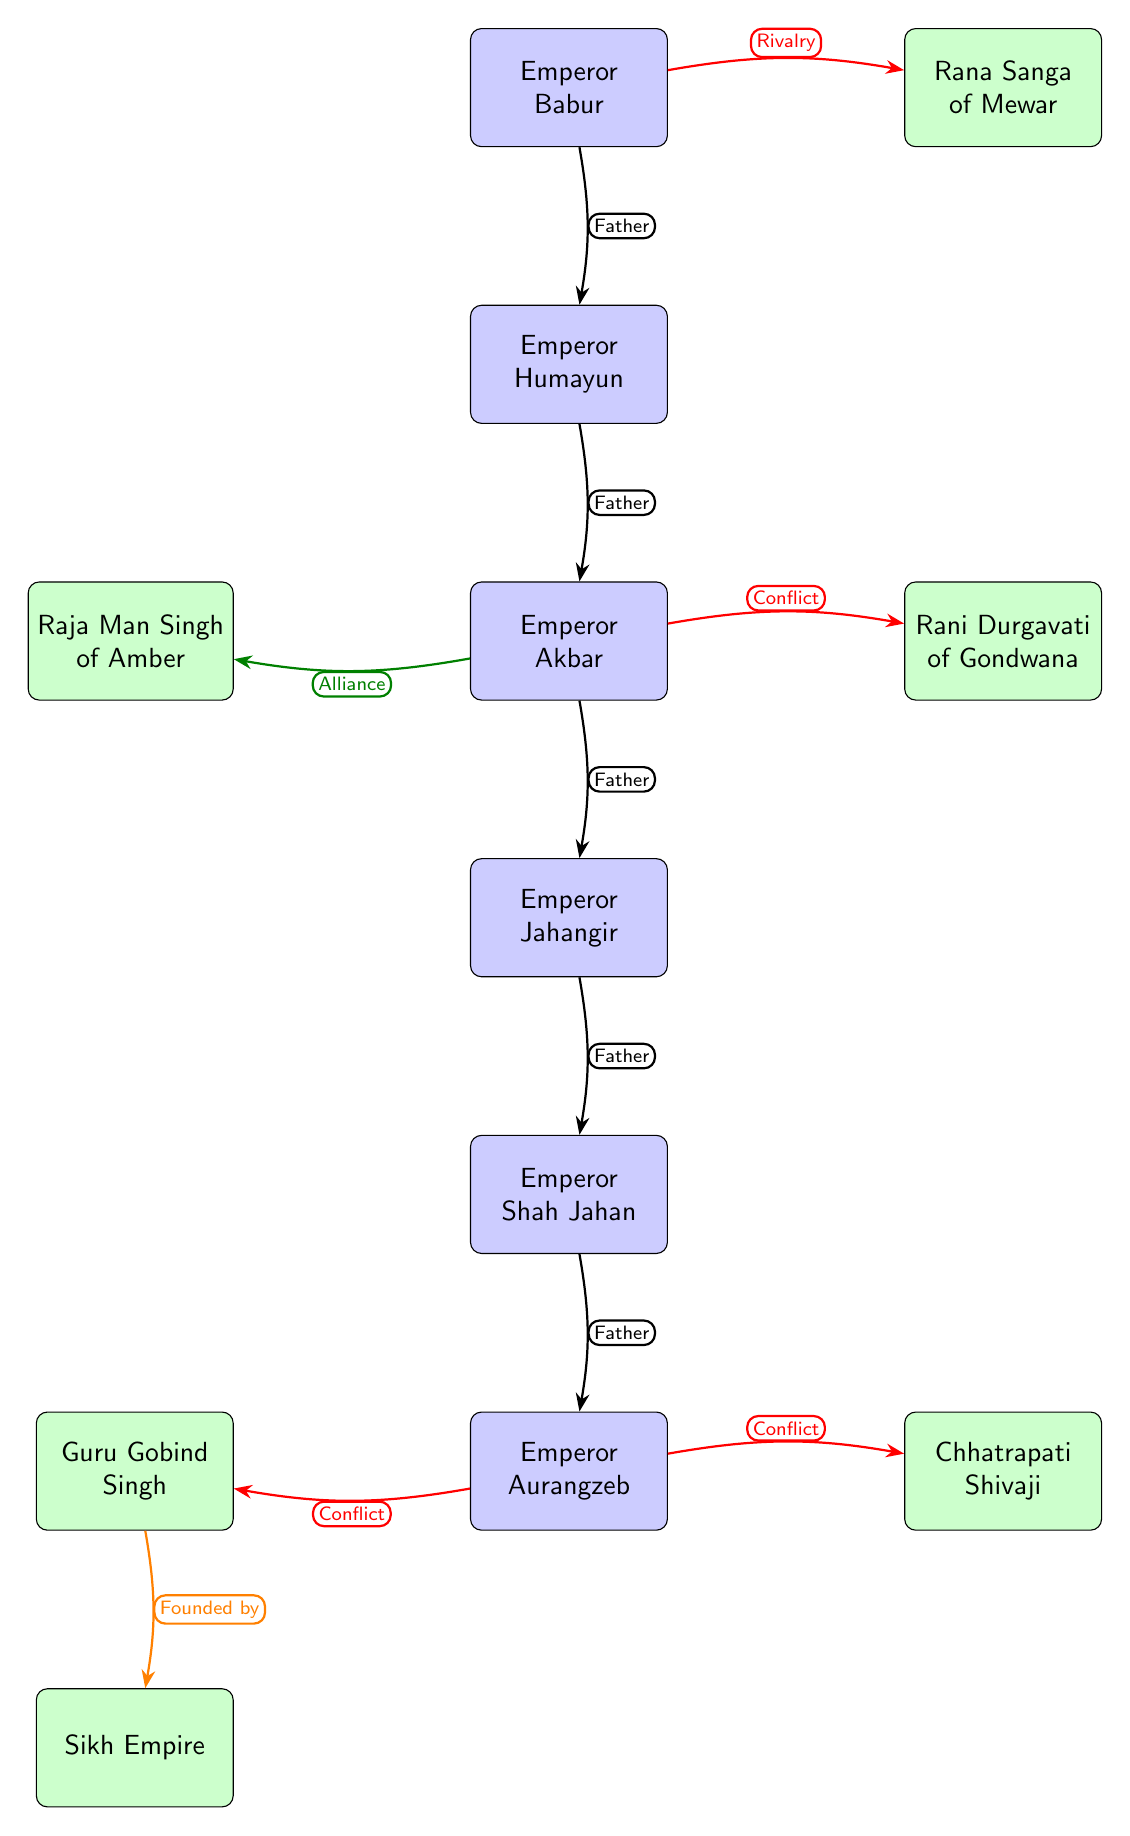What is the direct relationship between Babur and Humayun? The diagram shows a "Father" edge connecting Babur to Humayun, indicating that Babur is Humayun's father.
Answer: Father How many Mughal emperors are depicted in the diagram? The diagram contains a total of six Mughal emperors: Babur, Humayun, Akbar, Jahangir, Shah Jahan, and Aurangzeb.
Answer: 6 Which regional king is shown as having a rivalry with Babur? The edge labeled "Rivalry" connects Babur to Rana Sanga, indicating that Rana Sanga is shown as having a rivalry with him.
Answer: Rana Sanga What is the relationship between Akbar and Raja Man Singh? The diagram features an "Alliance" edge connecting Akbar to Raja Man Singh, indicating a cooperative relationship between them.
Answer: Alliance Which figure founded the Sikh Empire? The diagram indicates that Guru Gobind Singh is connected to the Sikh Empire with an edge labeled "Founded by," indicating he is the founder.
Answer: Guru Gobind Singh What type of conflict is shown between Aurangzeb and Shivaji? The diagram shows an edge labeled "Conflict" connecting Aurangzeb to Shivaji, indicating their relationship is one of conflict.
Answer: Conflict How many alliances are represented in the diagram? The diagram contains one alliance represented by the edge labeled "Alliance" connecting Akbar to Raja Man Singh.
Answer: 1 In which generation does Emperor Akbar appear within the Mughal genealogy? Counting from Babur at the top, Akbar appears in the third generation of the Mughal emperors as he is the son of Humayun and the grandson of Babur.
Answer: 3rd What relationship is represented between Akbar and Rani Durgavati? The diagram depicts a "Conflict" edge from Akbar to Rani Durgavati, suggesting a confrontational relationship.
Answer: Conflict 